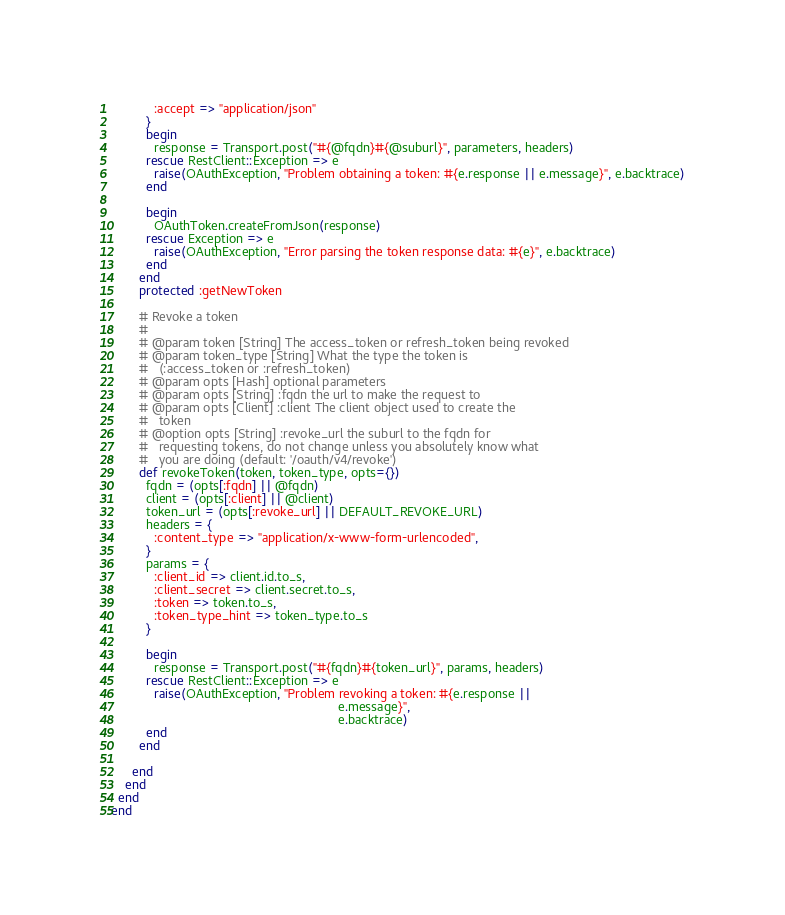<code> <loc_0><loc_0><loc_500><loc_500><_Ruby_>            :accept => "application/json"
          }
          begin
            response = Transport.post("#{@fqdn}#{@suburl}", parameters, headers)
          rescue RestClient::Exception => e
            raise(OAuthException, "Problem obtaining a token: #{e.response || e.message}", e.backtrace)
          end

          begin
            OAuthToken.createFromJson(response)
          rescue Exception => e
            raise(OAuthException, "Error parsing the token response data: #{e}", e.backtrace)
          end
        end
        protected :getNewToken

        # Revoke a token
        #
        # @param token [String] The access_token or refresh_token being revoked
        # @param token_type [String] What the type the token is
        #   (:access_token or :refresh_token)
        # @param opts [Hash] optional parameters 
        # @param opts [String] :fqdn the url to make the request to
        # @param opts [Client] :client The client object used to create the
        #   token
        # @option opts [String] :revoke_url the suburl to the fqdn for
        #   requesting tokens, do not change unless you absolutely know what
        #   you are doing (default: '/oauth/v4/revoke')
        def revokeToken(token, token_type, opts={})
          fqdn = (opts[:fqdn] || @fqdn)
          client = (opts[:client] || @client)
          token_url = (opts[:revoke_url] || DEFAULT_REVOKE_URL)
          headers = {
            :content_type => "application/x-www-form-urlencoded",
          }
          params = {
            :client_id => client.id.to_s,
            :client_secret => client.secret.to_s,
            :token => token.to_s,
            :token_type_hint => token_type.to_s
          }

          begin
            response = Transport.post("#{fqdn}#{token_url}", params, headers)
          rescue RestClient::Exception => e
            raise(OAuthException, "Problem revoking a token: #{e.response ||
                                                                e.message}",
                                                                e.backtrace)
          end
        end

      end
    end
  end
end
</code> 